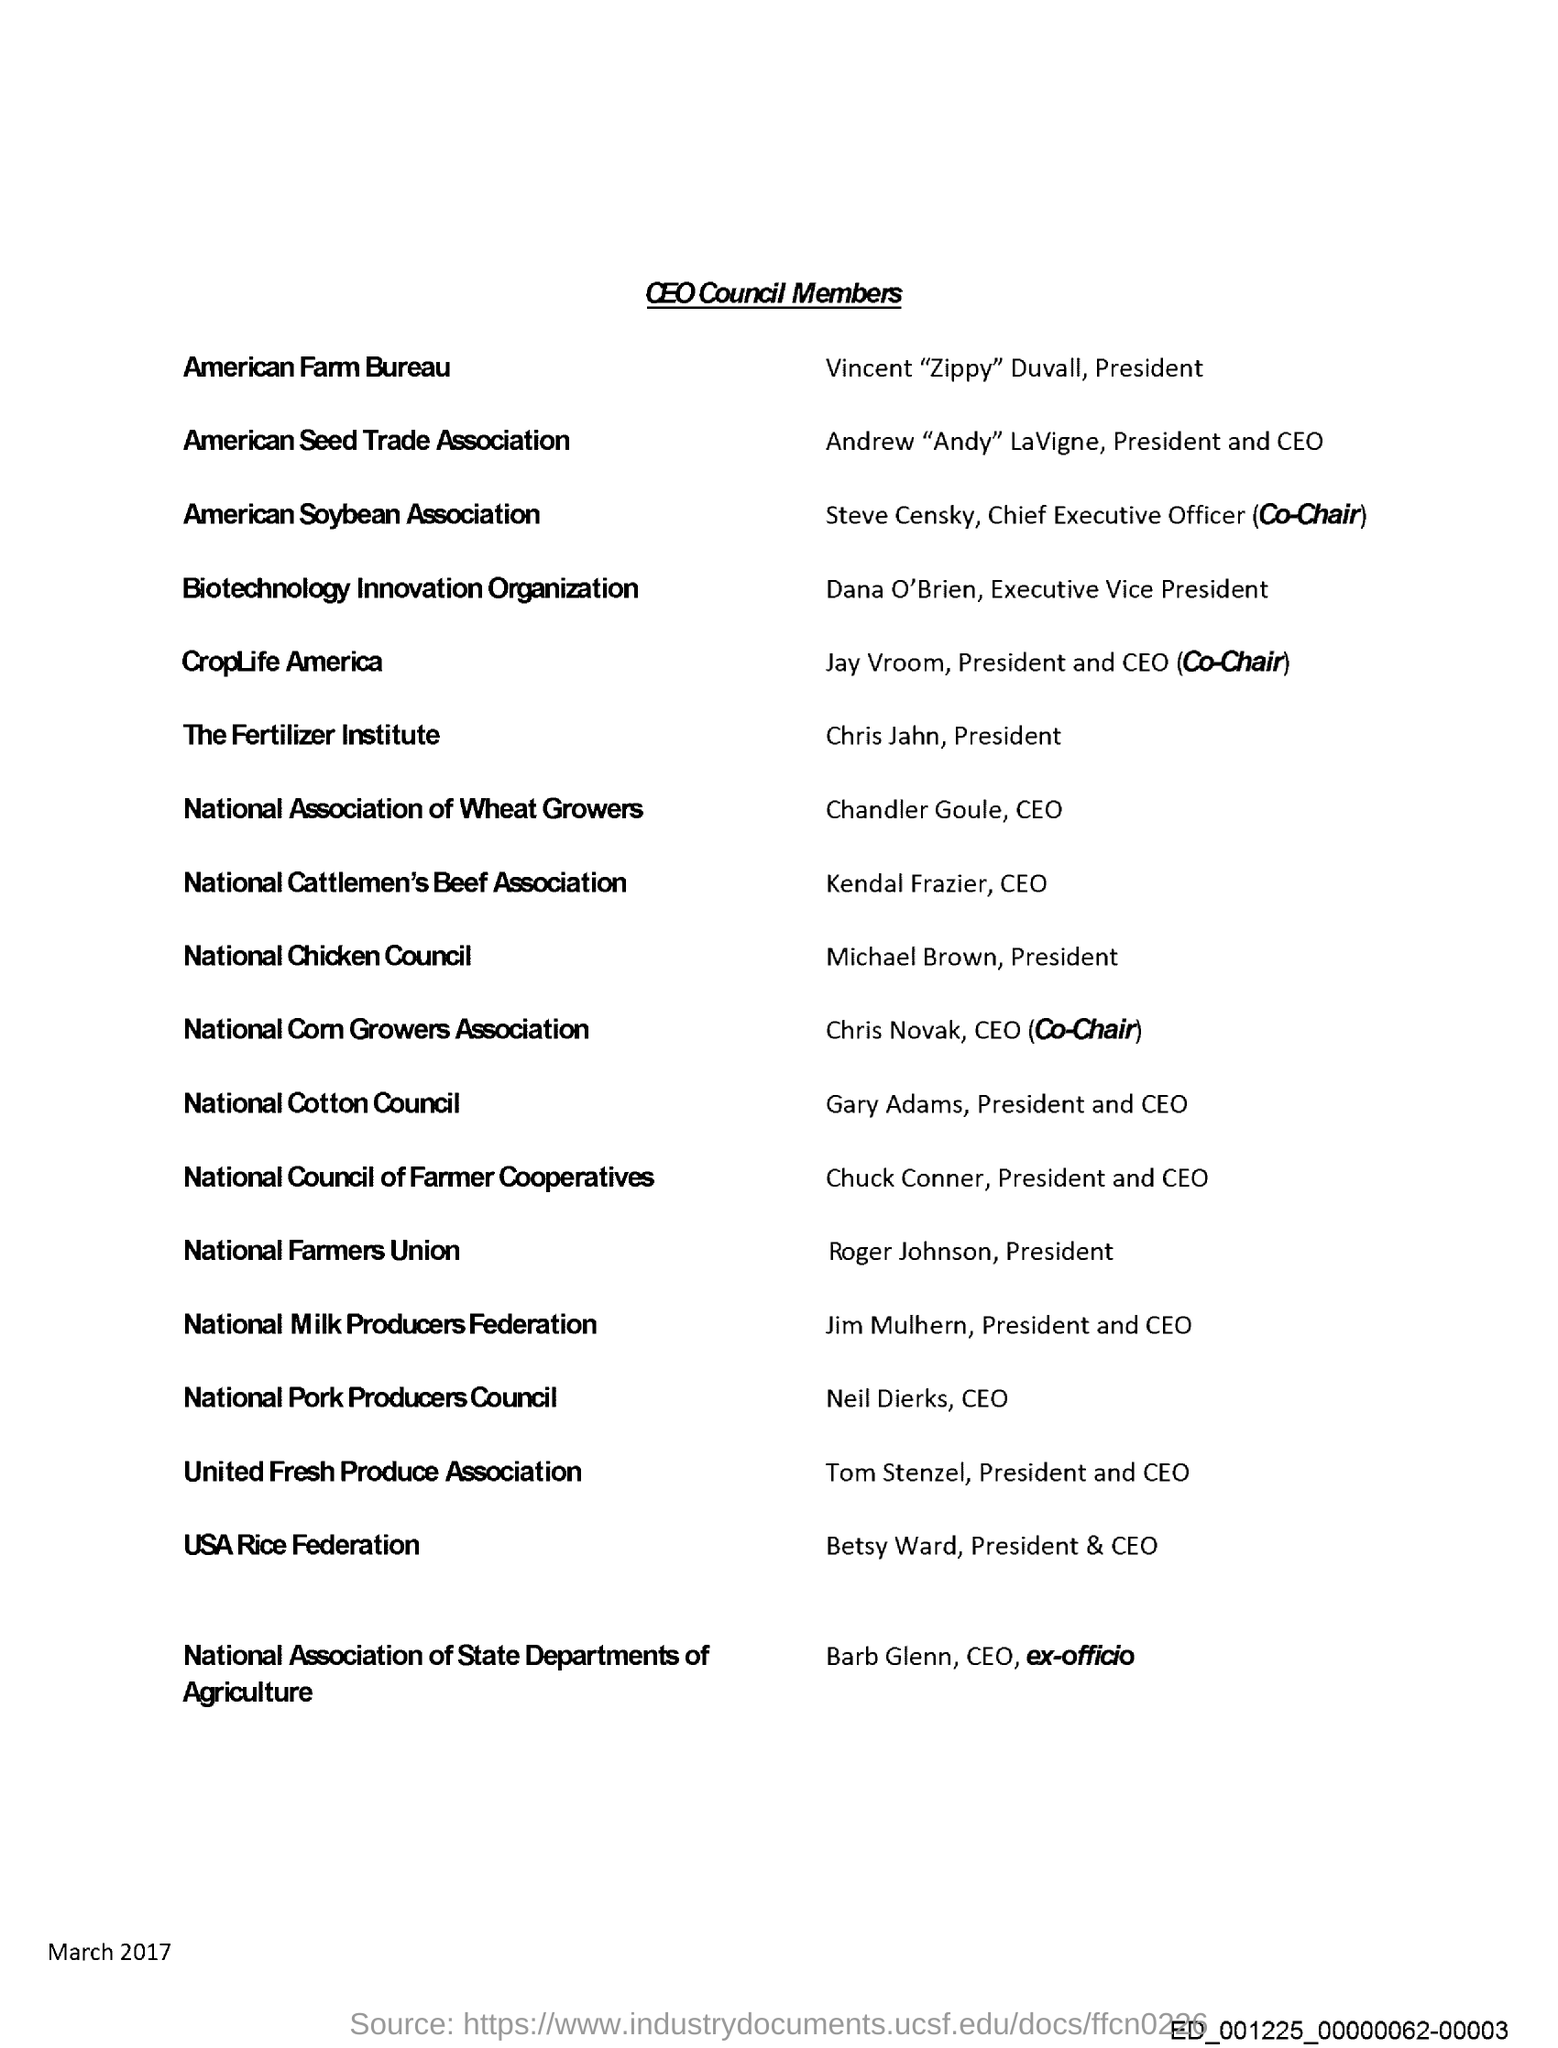What is the date mentioned in this document?
Your response must be concise. March 2017. Who is the President of The Fertilizer Institute?
Your answer should be very brief. Chris Jahn. Roger Johnson is associated with which union?
Provide a short and direct response. National Farmers Union. What is the title of this document?
Your answer should be compact. CEO Council Members. 